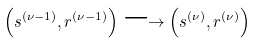Convert formula to latex. <formula><loc_0><loc_0><loc_500><loc_500>\left ( s ^ { ( \nu - 1 ) } , r ^ { ( \nu - 1 ) } \right ) \longrightarrow \left ( s ^ { ( \nu ) } , r ^ { ( \nu ) } \right )</formula> 